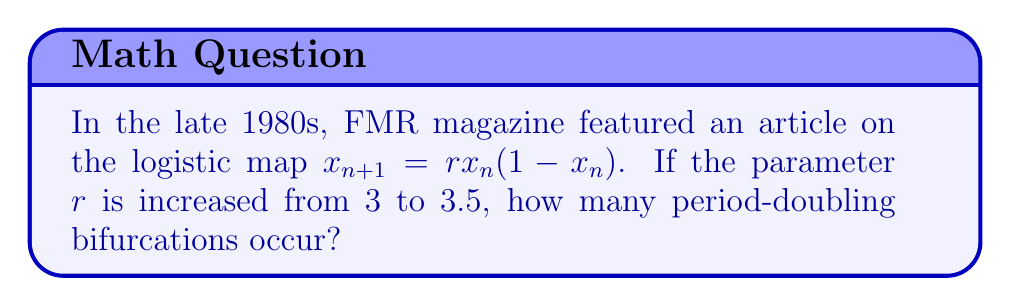Teach me how to tackle this problem. To solve this problem, we need to understand the behavior of the logistic map as the parameter $r$ increases:

1) For $1 < r < 3$, the map converges to a single fixed point.

2) At $r = 3$, the first period-doubling bifurcation occurs.

3) As $r$ increases beyond 3, we observe the following bifurcations:
   - At $r \approx 3.449$, the period-2 cycle becomes a period-4 cycle.
   - At $r \approx 3.544$, the period-4 cycle becomes a period-8 cycle.
   - At $r \approx 3.564$, the period-8 cycle becomes a period-16 cycle.

4) The bifurcations continue, with the intervals between them decreasing geometrically.

5) At $r \approx 3.57$, we reach the onset of chaos after infinitely many period-doubling bifurcations.

6) Given that we're increasing $r$ from 3 to 3.5, we need to count the number of bifurcations that occur in this range.

7) From the bifurcation points listed above, we can see that in the range $3 < r < 3.5$, we observe:
   - The initial bifurcation at $r = 3$ (period-1 to period-2)
   - The bifurcation at $r \approx 3.449$ (period-2 to period-4)

8) The next bifurcation at $r \approx 3.544$ is beyond our range of interest.

Therefore, in the given range, we observe 2 period-doubling bifurcations.
Answer: 2 